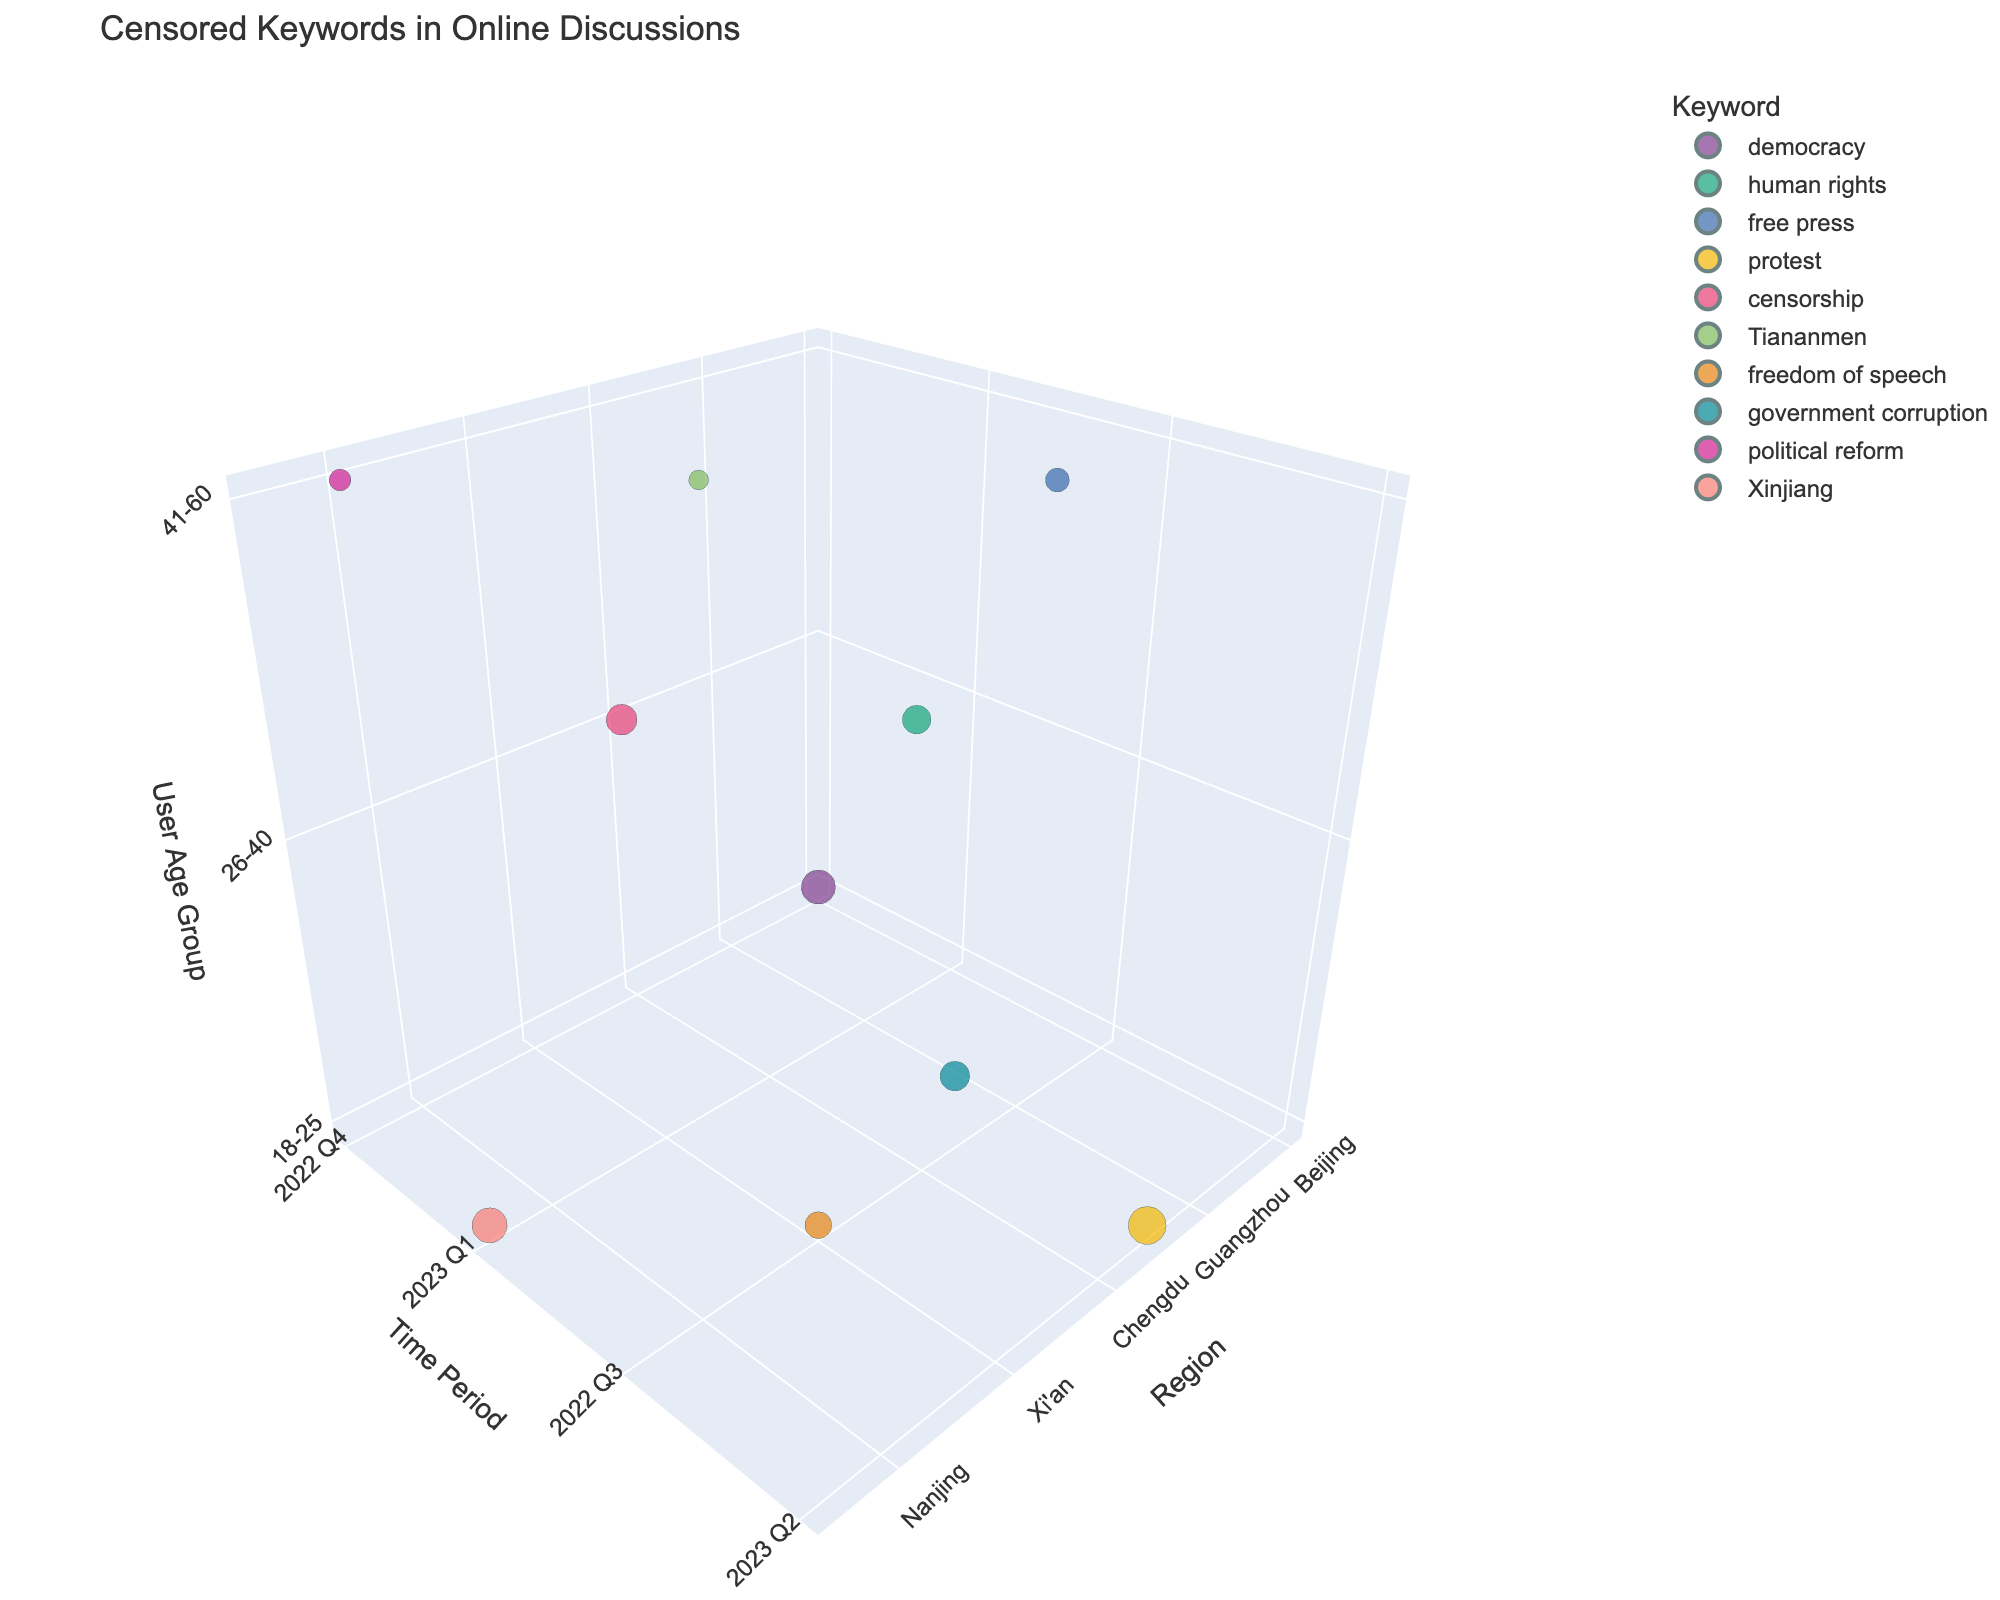What's the title of the figure? The title is usually located at the top of the figure and summarizes the main topic being visualized. In this case, it reads "Censored Keywords in Online Discussions."
Answer: Censored Keywords in Online Discussions How many different keywords are visualized in the chart? By checking the legend or the different colors representing the keywords, we can count a total of 10 distinct keywords.
Answer: 10 Which region has the highest frequency of the keyword "protest"? By locating the keyword "protest" and its corresponding size in the bubble chart, we find that Shenzhen has the highest frequency of 156.
Answer: Shenzhen What user age group and time period have the highest frequency for the keyword "democracy"? By identifying the bubble for "democracy" and examining its x, y, and z-axis values, we see it corresponds to user age group 18-25 and time period 2022 Q4.
Answer: 18-25, 2022 Q4 Which keyword appears in the age group 41-60 during the time period 2023 Q1? By analyzing the plot for the intersection of age group 41-60 and time period 2023 Q1, we observe the keyword "Tiananmen."
Answer: Tiananmen Among regions Beijing, Shanghai, and Guangzhou, which has the lowest frequency of any keyword? By comparing the bubble sizes for these regions, Guangzhou has the smallest bubble with a frequency of 62 for "free press."
Answer: Guangzhou What is the combined frequency of keywords for user age group 18-25 across all regions and periods? We add up the frequencies of keywords belonging to the age group 18-25: 127 (Beijing, "democracy") + 156 (Shenzhen, "protest") + 78 (Xi'an, "freedom of speech") + 134 (Chongqing, "Xinjiang") = 495.
Answer: 495 Which keyword has the smallest bubble size in the entire chart? By reviewing all the bubble sizes, the keyword "Tiananmen" in Wuhan during 2023 Q1 for age group 41-60 has the smallest bubble size with a frequency of 42.
Answer: Tiananmen What is the average frequency value of keywords for the age group 26-40? We find the frequencies for the age group 26-40: 89 (Shanghai), 103 (Chengdu), 95 (Hangzhou). The average is (89 + 103 + 95) / 3 = 95.67.
Answer: 95.67 